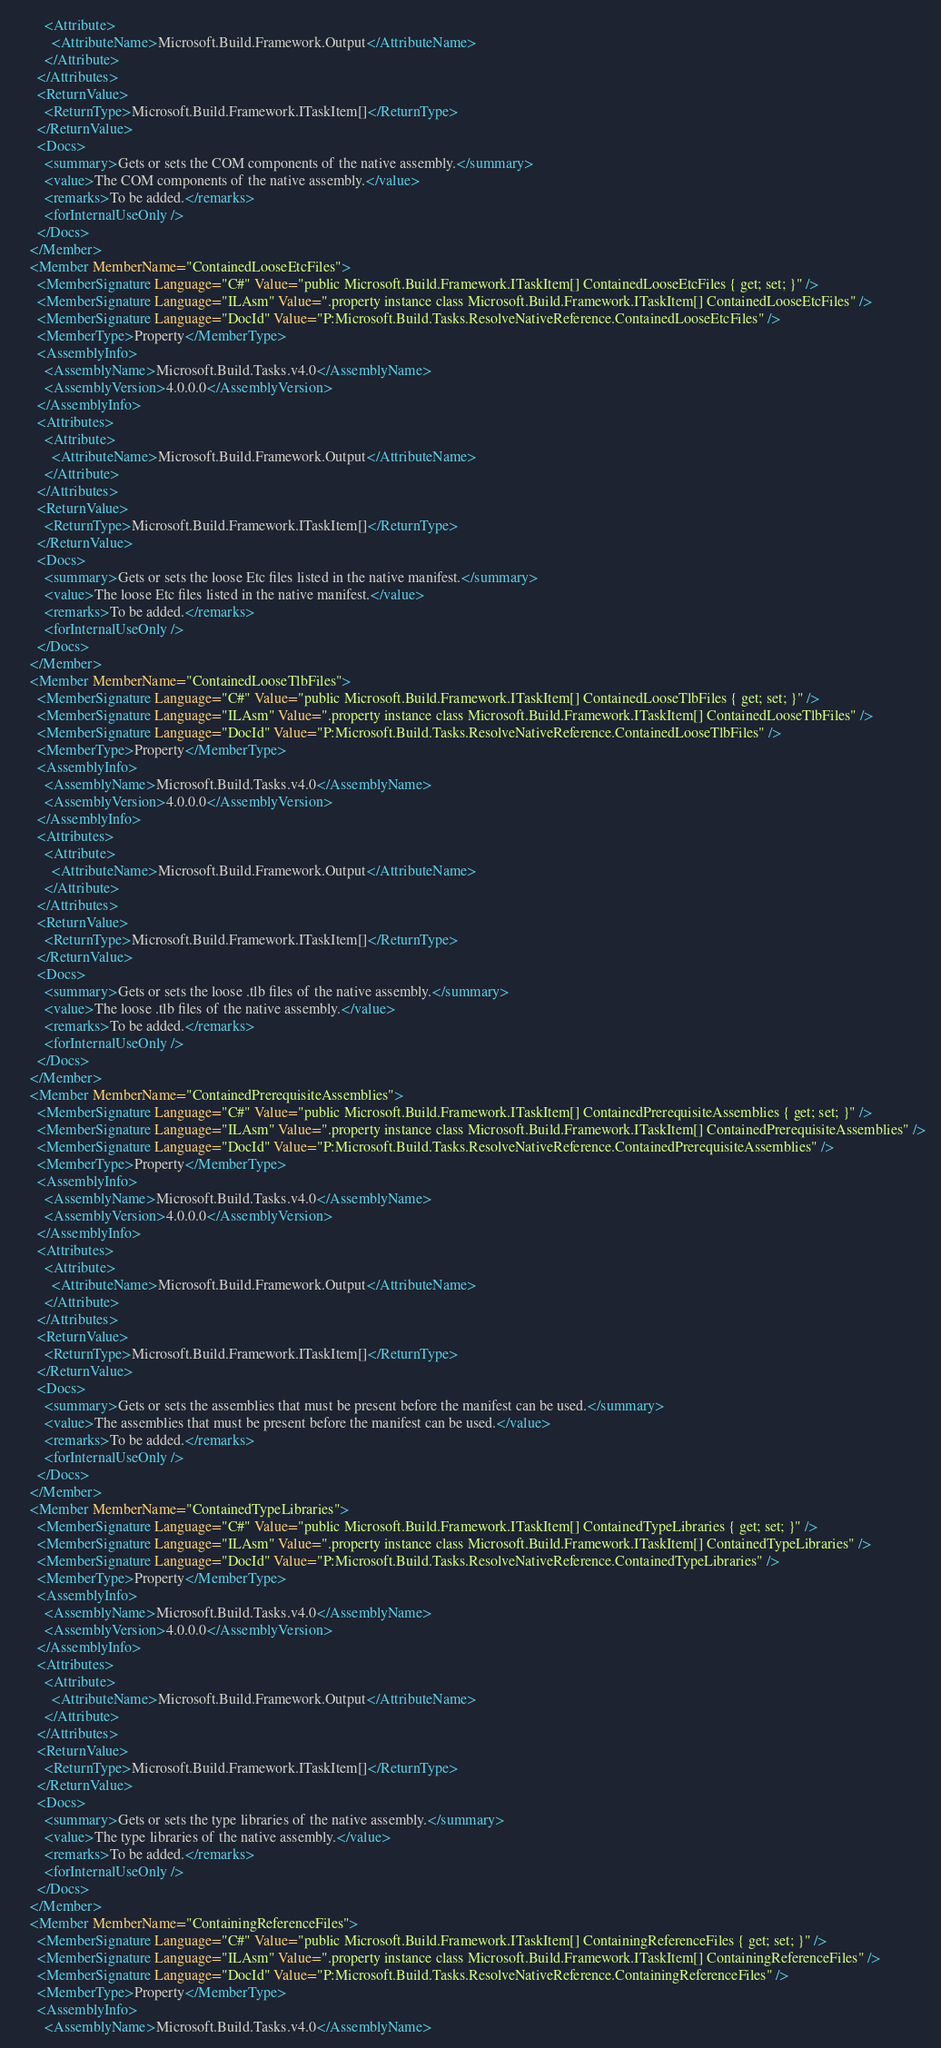<code> <loc_0><loc_0><loc_500><loc_500><_XML_>        <Attribute>
          <AttributeName>Microsoft.Build.Framework.Output</AttributeName>
        </Attribute>
      </Attributes>
      <ReturnValue>
        <ReturnType>Microsoft.Build.Framework.ITaskItem[]</ReturnType>
      </ReturnValue>
      <Docs>
        <summary>Gets or sets the COM components of the native assembly.</summary>
        <value>The COM components of the native assembly.</value>
        <remarks>To be added.</remarks>
        <forInternalUseOnly />
      </Docs>
    </Member>
    <Member MemberName="ContainedLooseEtcFiles">
      <MemberSignature Language="C#" Value="public Microsoft.Build.Framework.ITaskItem[] ContainedLooseEtcFiles { get; set; }" />
      <MemberSignature Language="ILAsm" Value=".property instance class Microsoft.Build.Framework.ITaskItem[] ContainedLooseEtcFiles" />
      <MemberSignature Language="DocId" Value="P:Microsoft.Build.Tasks.ResolveNativeReference.ContainedLooseEtcFiles" />
      <MemberType>Property</MemberType>
      <AssemblyInfo>
        <AssemblyName>Microsoft.Build.Tasks.v4.0</AssemblyName>
        <AssemblyVersion>4.0.0.0</AssemblyVersion>
      </AssemblyInfo>
      <Attributes>
        <Attribute>
          <AttributeName>Microsoft.Build.Framework.Output</AttributeName>
        </Attribute>
      </Attributes>
      <ReturnValue>
        <ReturnType>Microsoft.Build.Framework.ITaskItem[]</ReturnType>
      </ReturnValue>
      <Docs>
        <summary>Gets or sets the loose Etc files listed in the native manifest.</summary>
        <value>The loose Etc files listed in the native manifest.</value>
        <remarks>To be added.</remarks>
        <forInternalUseOnly />
      </Docs>
    </Member>
    <Member MemberName="ContainedLooseTlbFiles">
      <MemberSignature Language="C#" Value="public Microsoft.Build.Framework.ITaskItem[] ContainedLooseTlbFiles { get; set; }" />
      <MemberSignature Language="ILAsm" Value=".property instance class Microsoft.Build.Framework.ITaskItem[] ContainedLooseTlbFiles" />
      <MemberSignature Language="DocId" Value="P:Microsoft.Build.Tasks.ResolveNativeReference.ContainedLooseTlbFiles" />
      <MemberType>Property</MemberType>
      <AssemblyInfo>
        <AssemblyName>Microsoft.Build.Tasks.v4.0</AssemblyName>
        <AssemblyVersion>4.0.0.0</AssemblyVersion>
      </AssemblyInfo>
      <Attributes>
        <Attribute>
          <AttributeName>Microsoft.Build.Framework.Output</AttributeName>
        </Attribute>
      </Attributes>
      <ReturnValue>
        <ReturnType>Microsoft.Build.Framework.ITaskItem[]</ReturnType>
      </ReturnValue>
      <Docs>
        <summary>Gets or sets the loose .tlb files of the native assembly.</summary>
        <value>The loose .tlb files of the native assembly.</value>
        <remarks>To be added.</remarks>
        <forInternalUseOnly />
      </Docs>
    </Member>
    <Member MemberName="ContainedPrerequisiteAssemblies">
      <MemberSignature Language="C#" Value="public Microsoft.Build.Framework.ITaskItem[] ContainedPrerequisiteAssemblies { get; set; }" />
      <MemberSignature Language="ILAsm" Value=".property instance class Microsoft.Build.Framework.ITaskItem[] ContainedPrerequisiteAssemblies" />
      <MemberSignature Language="DocId" Value="P:Microsoft.Build.Tasks.ResolveNativeReference.ContainedPrerequisiteAssemblies" />
      <MemberType>Property</MemberType>
      <AssemblyInfo>
        <AssemblyName>Microsoft.Build.Tasks.v4.0</AssemblyName>
        <AssemblyVersion>4.0.0.0</AssemblyVersion>
      </AssemblyInfo>
      <Attributes>
        <Attribute>
          <AttributeName>Microsoft.Build.Framework.Output</AttributeName>
        </Attribute>
      </Attributes>
      <ReturnValue>
        <ReturnType>Microsoft.Build.Framework.ITaskItem[]</ReturnType>
      </ReturnValue>
      <Docs>
        <summary>Gets or sets the assemblies that must be present before the manifest can be used.</summary>
        <value>The assemblies that must be present before the manifest can be used.</value>
        <remarks>To be added.</remarks>
        <forInternalUseOnly />
      </Docs>
    </Member>
    <Member MemberName="ContainedTypeLibraries">
      <MemberSignature Language="C#" Value="public Microsoft.Build.Framework.ITaskItem[] ContainedTypeLibraries { get; set; }" />
      <MemberSignature Language="ILAsm" Value=".property instance class Microsoft.Build.Framework.ITaskItem[] ContainedTypeLibraries" />
      <MemberSignature Language="DocId" Value="P:Microsoft.Build.Tasks.ResolveNativeReference.ContainedTypeLibraries" />
      <MemberType>Property</MemberType>
      <AssemblyInfo>
        <AssemblyName>Microsoft.Build.Tasks.v4.0</AssemblyName>
        <AssemblyVersion>4.0.0.0</AssemblyVersion>
      </AssemblyInfo>
      <Attributes>
        <Attribute>
          <AttributeName>Microsoft.Build.Framework.Output</AttributeName>
        </Attribute>
      </Attributes>
      <ReturnValue>
        <ReturnType>Microsoft.Build.Framework.ITaskItem[]</ReturnType>
      </ReturnValue>
      <Docs>
        <summary>Gets or sets the type libraries of the native assembly.</summary>
        <value>The type libraries of the native assembly.</value>
        <remarks>To be added.</remarks>
        <forInternalUseOnly />
      </Docs>
    </Member>
    <Member MemberName="ContainingReferenceFiles">
      <MemberSignature Language="C#" Value="public Microsoft.Build.Framework.ITaskItem[] ContainingReferenceFiles { get; set; }" />
      <MemberSignature Language="ILAsm" Value=".property instance class Microsoft.Build.Framework.ITaskItem[] ContainingReferenceFiles" />
      <MemberSignature Language="DocId" Value="P:Microsoft.Build.Tasks.ResolveNativeReference.ContainingReferenceFiles" />
      <MemberType>Property</MemberType>
      <AssemblyInfo>
        <AssemblyName>Microsoft.Build.Tasks.v4.0</AssemblyName></code> 